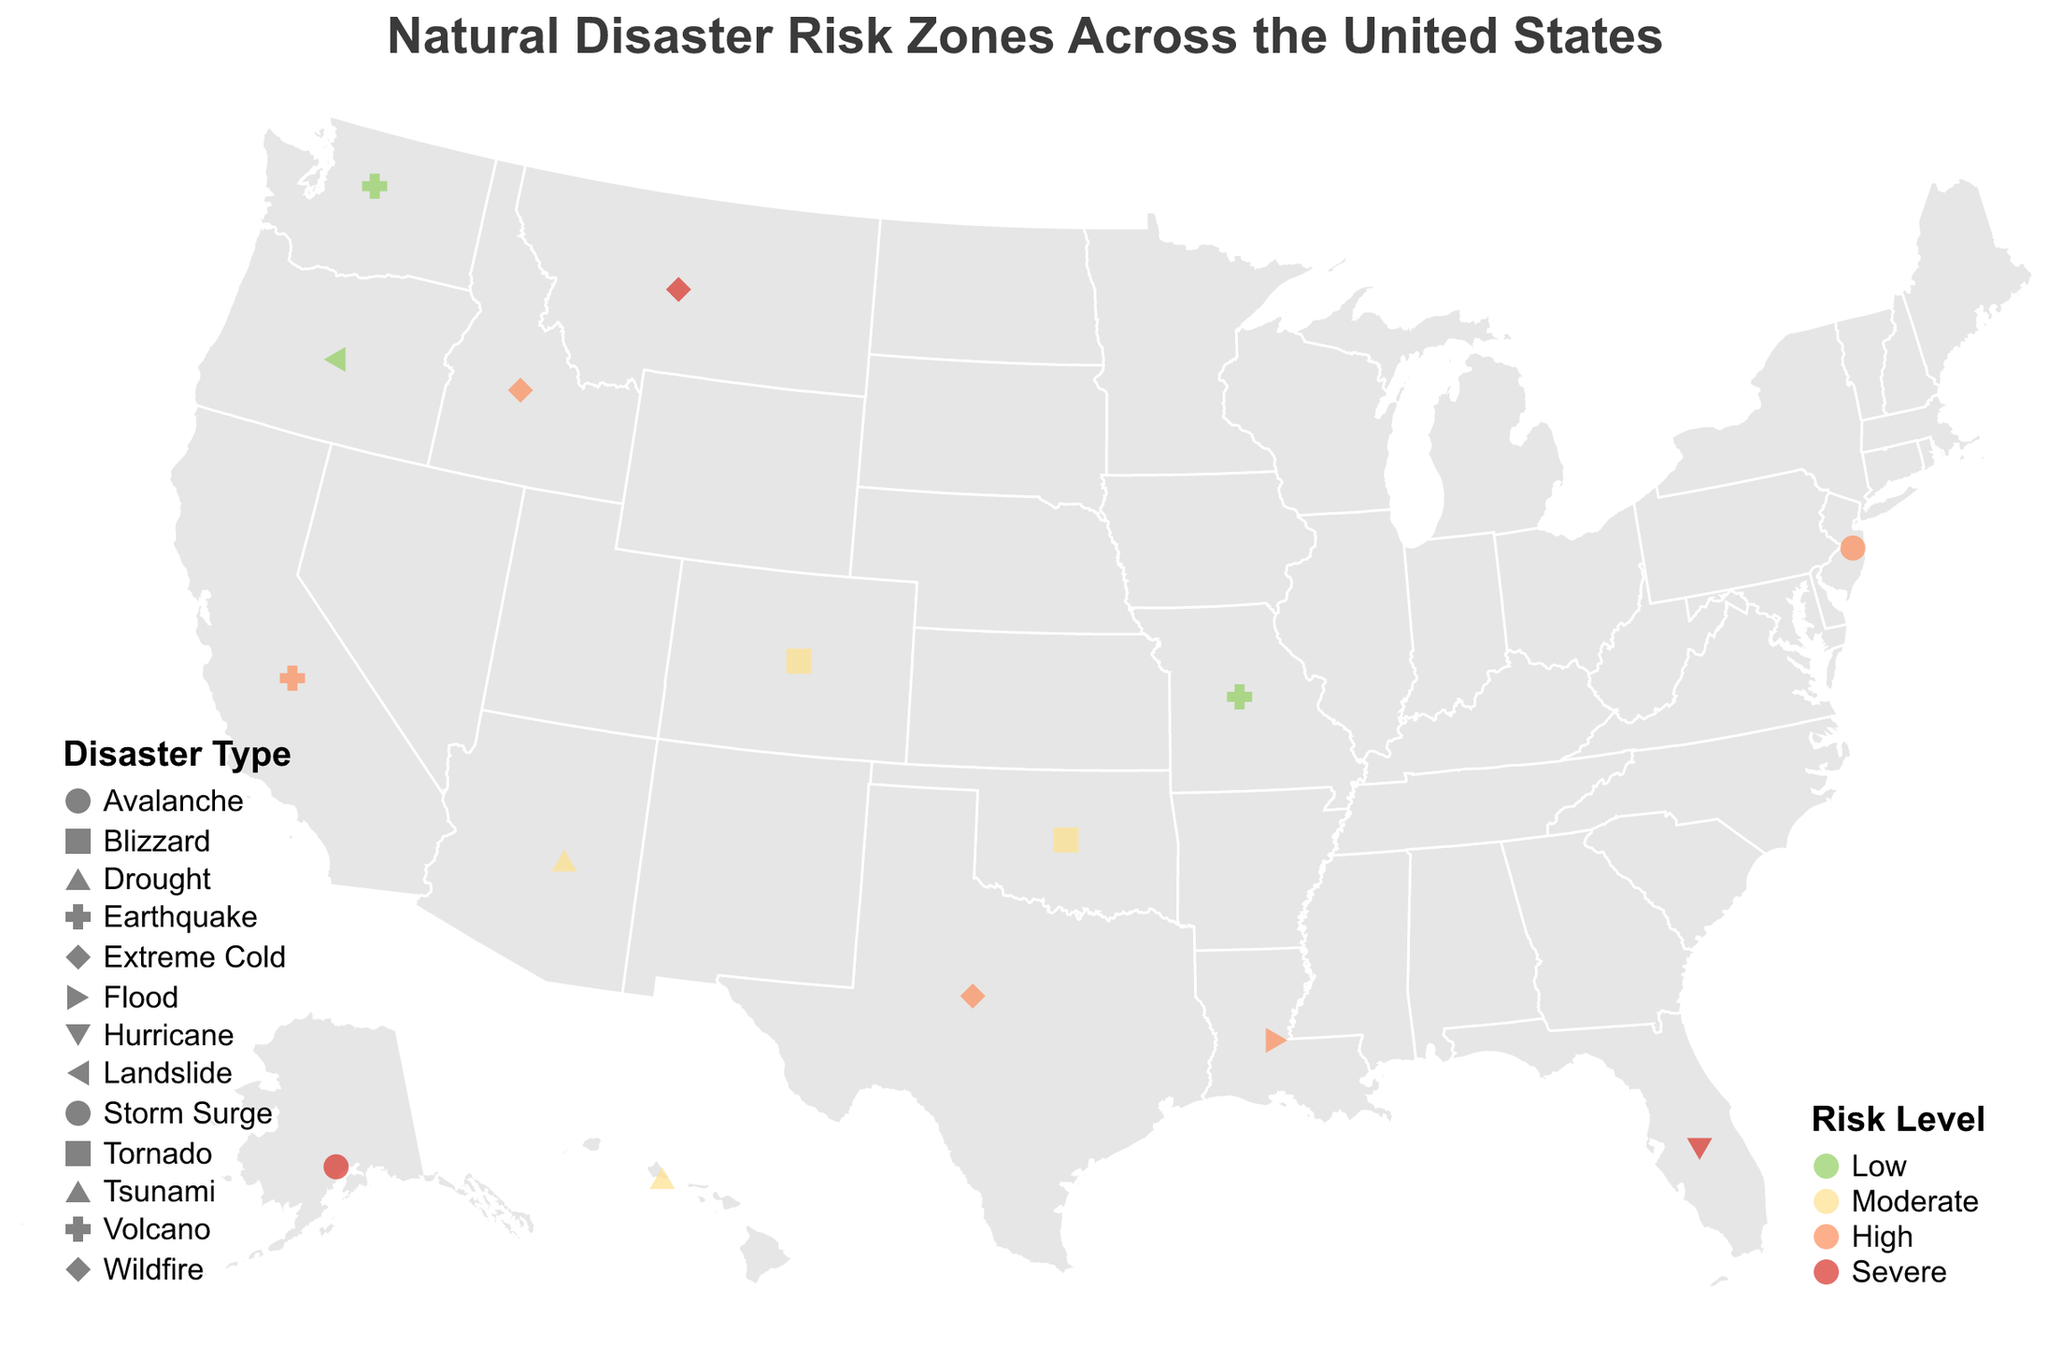What is the highest risk level in California? California is represented in the figure with a color indicating "High" risk level.
Answer: High Which region has a severe risk level for hurricanes? Look for the color and shape representing "Severe" risk and "Hurricane" in the tooltip information.
Answer: Florida Count the number of regions with a severe risk level. Identify all points colored with the "Severe" color and count them.
Answer: 3 Which disaster type is represented in Washington? Locate Washington on the map and check the information in the tooltip for that point.
Answer: Volcano Compare the risk levels of Texas and Idaho for wildfires. Locate Texas and Idaho on the map and observe their colors indicating risk levels. Texas has a "High" risk level and Idaho also has a "High" risk level.
Answer: Equal Which region has the lowest risk of landslides? Landslide is indicated by a specific shape and the lowest risk level is colored by the "Low" risk color.
Answer: Oregon How many types of disasters are plotted on the map? Different shapes represent different disaster types. Count the unique shapes or tooltip information for disaster types.
Answer: 14 What is the risk level for avalanches in Alaska? Locate Alaska on the map and check the information in the tooltip for that point which represents an avalanche.
Answer: Severe What is the color indication for moderate risk level, and provide an example region? Observe the color legend for "Moderate" risk and find a region such as Oklahoma.
Answer: Yellowish color; Oklahoma Compare the geographical distribution of high-risk flood zones to that of high-risk wildfire zones. High-risk flood and wildfire zones have specific colors and can be compared by locating Louisiana (flood) and Texas/Idaho (wildfire) on the map.
Answer: Louisiana (Flood); Texas and Idaho (Wildfire) 